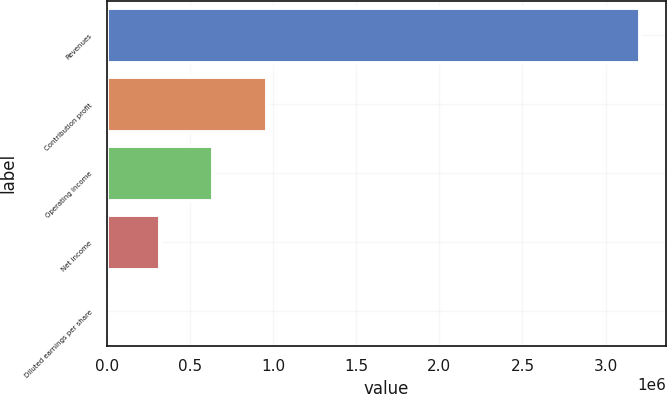<chart> <loc_0><loc_0><loc_500><loc_500><bar_chart><fcel>Revenues<fcel>Contribution profit<fcel>Operating income<fcel>Net income<fcel>Diluted earnings per share<nl><fcel>3.20458e+06<fcel>961376<fcel>640919<fcel>320461<fcel>4.16<nl></chart> 